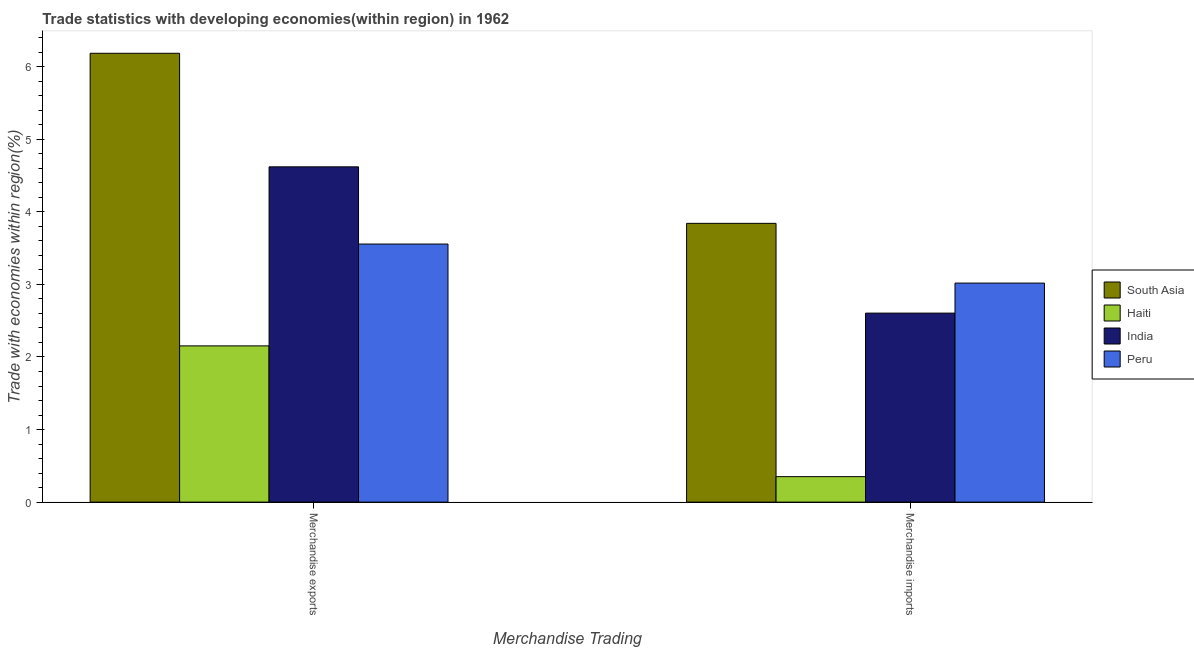How many different coloured bars are there?
Keep it short and to the point. 4. How many groups of bars are there?
Keep it short and to the point. 2. Are the number of bars on each tick of the X-axis equal?
Offer a very short reply. Yes. How many bars are there on the 2nd tick from the right?
Your answer should be very brief. 4. What is the label of the 1st group of bars from the left?
Offer a terse response. Merchandise exports. What is the merchandise imports in India?
Your response must be concise. 2.6. Across all countries, what is the maximum merchandise exports?
Give a very brief answer. 6.19. Across all countries, what is the minimum merchandise imports?
Offer a terse response. 0.35. In which country was the merchandise imports maximum?
Ensure brevity in your answer.  South Asia. In which country was the merchandise exports minimum?
Offer a very short reply. Haiti. What is the total merchandise exports in the graph?
Your answer should be very brief. 16.52. What is the difference between the merchandise imports in South Asia and that in Haiti?
Your answer should be compact. 3.49. What is the difference between the merchandise imports in India and the merchandise exports in Haiti?
Make the answer very short. 0.45. What is the average merchandise imports per country?
Ensure brevity in your answer.  2.45. What is the difference between the merchandise exports and merchandise imports in South Asia?
Ensure brevity in your answer.  2.34. What is the ratio of the merchandise imports in South Asia to that in Haiti?
Give a very brief answer. 10.94. What does the 3rd bar from the left in Merchandise imports represents?
Keep it short and to the point. India. What does the 4th bar from the right in Merchandise exports represents?
Provide a succinct answer. South Asia. How many bars are there?
Provide a succinct answer. 8. Are all the bars in the graph horizontal?
Your answer should be compact. No. What is the difference between two consecutive major ticks on the Y-axis?
Offer a terse response. 1. Are the values on the major ticks of Y-axis written in scientific E-notation?
Offer a terse response. No. How many legend labels are there?
Your response must be concise. 4. What is the title of the graph?
Offer a terse response. Trade statistics with developing economies(within region) in 1962. Does "Upper middle income" appear as one of the legend labels in the graph?
Provide a succinct answer. No. What is the label or title of the X-axis?
Provide a succinct answer. Merchandise Trading. What is the label or title of the Y-axis?
Make the answer very short. Trade with economies within region(%). What is the Trade with economies within region(%) of South Asia in Merchandise exports?
Keep it short and to the point. 6.19. What is the Trade with economies within region(%) in Haiti in Merchandise exports?
Provide a succinct answer. 2.15. What is the Trade with economies within region(%) of India in Merchandise exports?
Your answer should be compact. 4.62. What is the Trade with economies within region(%) in Peru in Merchandise exports?
Provide a succinct answer. 3.56. What is the Trade with economies within region(%) of South Asia in Merchandise imports?
Your answer should be very brief. 3.84. What is the Trade with economies within region(%) of Haiti in Merchandise imports?
Your response must be concise. 0.35. What is the Trade with economies within region(%) in India in Merchandise imports?
Your answer should be compact. 2.6. What is the Trade with economies within region(%) of Peru in Merchandise imports?
Your response must be concise. 3.02. Across all Merchandise Trading, what is the maximum Trade with economies within region(%) of South Asia?
Your answer should be very brief. 6.19. Across all Merchandise Trading, what is the maximum Trade with economies within region(%) of Haiti?
Offer a terse response. 2.15. Across all Merchandise Trading, what is the maximum Trade with economies within region(%) of India?
Give a very brief answer. 4.62. Across all Merchandise Trading, what is the maximum Trade with economies within region(%) of Peru?
Keep it short and to the point. 3.56. Across all Merchandise Trading, what is the minimum Trade with economies within region(%) in South Asia?
Offer a terse response. 3.84. Across all Merchandise Trading, what is the minimum Trade with economies within region(%) of Haiti?
Provide a short and direct response. 0.35. Across all Merchandise Trading, what is the minimum Trade with economies within region(%) of India?
Provide a short and direct response. 2.6. Across all Merchandise Trading, what is the minimum Trade with economies within region(%) in Peru?
Offer a very short reply. 3.02. What is the total Trade with economies within region(%) of South Asia in the graph?
Your response must be concise. 10.03. What is the total Trade with economies within region(%) of Haiti in the graph?
Offer a very short reply. 2.5. What is the total Trade with economies within region(%) of India in the graph?
Provide a short and direct response. 7.23. What is the total Trade with economies within region(%) in Peru in the graph?
Your answer should be compact. 6.57. What is the difference between the Trade with economies within region(%) of South Asia in Merchandise exports and that in Merchandise imports?
Your response must be concise. 2.34. What is the difference between the Trade with economies within region(%) of Haiti in Merchandise exports and that in Merchandise imports?
Give a very brief answer. 1.8. What is the difference between the Trade with economies within region(%) in India in Merchandise exports and that in Merchandise imports?
Make the answer very short. 2.02. What is the difference between the Trade with economies within region(%) in Peru in Merchandise exports and that in Merchandise imports?
Offer a very short reply. 0.54. What is the difference between the Trade with economies within region(%) in South Asia in Merchandise exports and the Trade with economies within region(%) in Haiti in Merchandise imports?
Your answer should be compact. 5.83. What is the difference between the Trade with economies within region(%) of South Asia in Merchandise exports and the Trade with economies within region(%) of India in Merchandise imports?
Offer a terse response. 3.58. What is the difference between the Trade with economies within region(%) of South Asia in Merchandise exports and the Trade with economies within region(%) of Peru in Merchandise imports?
Your answer should be compact. 3.17. What is the difference between the Trade with economies within region(%) of Haiti in Merchandise exports and the Trade with economies within region(%) of India in Merchandise imports?
Ensure brevity in your answer.  -0.45. What is the difference between the Trade with economies within region(%) in Haiti in Merchandise exports and the Trade with economies within region(%) in Peru in Merchandise imports?
Keep it short and to the point. -0.87. What is the difference between the Trade with economies within region(%) of India in Merchandise exports and the Trade with economies within region(%) of Peru in Merchandise imports?
Offer a very short reply. 1.6. What is the average Trade with economies within region(%) of South Asia per Merchandise Trading?
Your answer should be compact. 5.01. What is the average Trade with economies within region(%) in Haiti per Merchandise Trading?
Provide a succinct answer. 1.25. What is the average Trade with economies within region(%) in India per Merchandise Trading?
Offer a terse response. 3.61. What is the average Trade with economies within region(%) of Peru per Merchandise Trading?
Ensure brevity in your answer.  3.29. What is the difference between the Trade with economies within region(%) of South Asia and Trade with economies within region(%) of Haiti in Merchandise exports?
Your answer should be compact. 4.03. What is the difference between the Trade with economies within region(%) of South Asia and Trade with economies within region(%) of India in Merchandise exports?
Your response must be concise. 1.57. What is the difference between the Trade with economies within region(%) in South Asia and Trade with economies within region(%) in Peru in Merchandise exports?
Provide a short and direct response. 2.63. What is the difference between the Trade with economies within region(%) in Haiti and Trade with economies within region(%) in India in Merchandise exports?
Your answer should be compact. -2.47. What is the difference between the Trade with economies within region(%) of Haiti and Trade with economies within region(%) of Peru in Merchandise exports?
Your answer should be very brief. -1.4. What is the difference between the Trade with economies within region(%) of India and Trade with economies within region(%) of Peru in Merchandise exports?
Your response must be concise. 1.06. What is the difference between the Trade with economies within region(%) in South Asia and Trade with economies within region(%) in Haiti in Merchandise imports?
Offer a terse response. 3.49. What is the difference between the Trade with economies within region(%) in South Asia and Trade with economies within region(%) in India in Merchandise imports?
Offer a terse response. 1.24. What is the difference between the Trade with economies within region(%) in South Asia and Trade with economies within region(%) in Peru in Merchandise imports?
Keep it short and to the point. 0.82. What is the difference between the Trade with economies within region(%) of Haiti and Trade with economies within region(%) of India in Merchandise imports?
Provide a succinct answer. -2.25. What is the difference between the Trade with economies within region(%) in Haiti and Trade with economies within region(%) in Peru in Merchandise imports?
Ensure brevity in your answer.  -2.67. What is the difference between the Trade with economies within region(%) in India and Trade with economies within region(%) in Peru in Merchandise imports?
Provide a short and direct response. -0.41. What is the ratio of the Trade with economies within region(%) in South Asia in Merchandise exports to that in Merchandise imports?
Offer a very short reply. 1.61. What is the ratio of the Trade with economies within region(%) of Haiti in Merchandise exports to that in Merchandise imports?
Keep it short and to the point. 6.13. What is the ratio of the Trade with economies within region(%) of India in Merchandise exports to that in Merchandise imports?
Offer a terse response. 1.77. What is the ratio of the Trade with economies within region(%) of Peru in Merchandise exports to that in Merchandise imports?
Provide a short and direct response. 1.18. What is the difference between the highest and the second highest Trade with economies within region(%) in South Asia?
Provide a short and direct response. 2.34. What is the difference between the highest and the second highest Trade with economies within region(%) in Haiti?
Offer a very short reply. 1.8. What is the difference between the highest and the second highest Trade with economies within region(%) of India?
Keep it short and to the point. 2.02. What is the difference between the highest and the second highest Trade with economies within region(%) of Peru?
Offer a terse response. 0.54. What is the difference between the highest and the lowest Trade with economies within region(%) of South Asia?
Ensure brevity in your answer.  2.34. What is the difference between the highest and the lowest Trade with economies within region(%) of Haiti?
Make the answer very short. 1.8. What is the difference between the highest and the lowest Trade with economies within region(%) of India?
Provide a short and direct response. 2.02. What is the difference between the highest and the lowest Trade with economies within region(%) in Peru?
Offer a terse response. 0.54. 